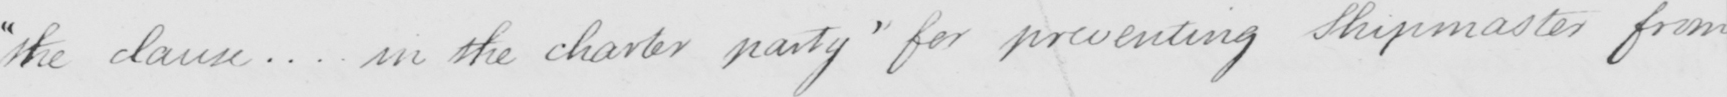Please provide the text content of this handwritten line. " the clause .. . in the chapter party "  for preventing Shipmasters from 